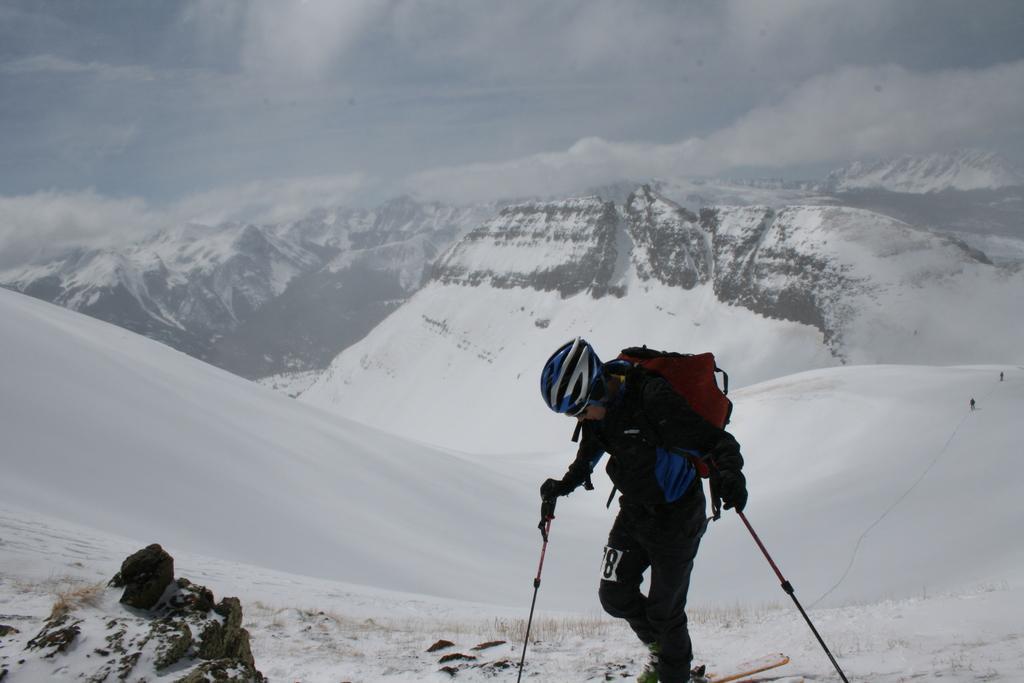How would you summarize this image in a sentence or two? In the middle of the image a man is doing skating and holding sticks. Behind him there are some hills and snow. At the top of the image there are some clouds and sky. 